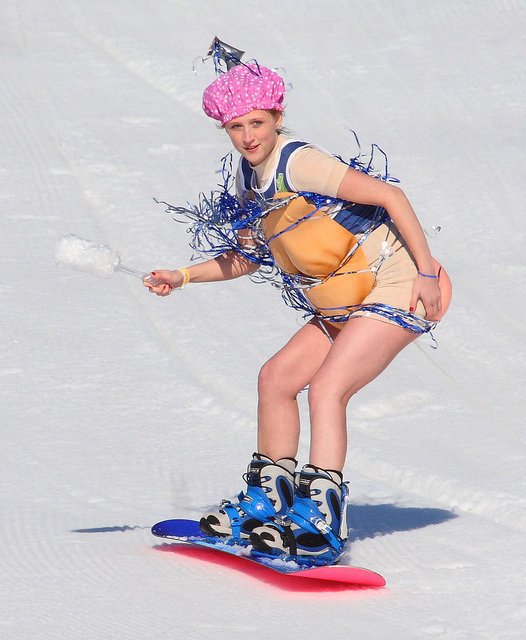<image>Is the snow deep? I am not sure if the snow is deep. It can be both deep and not deep. Is the snow deep? I don't know if the snow is deep. It can be both deep and not deep. 